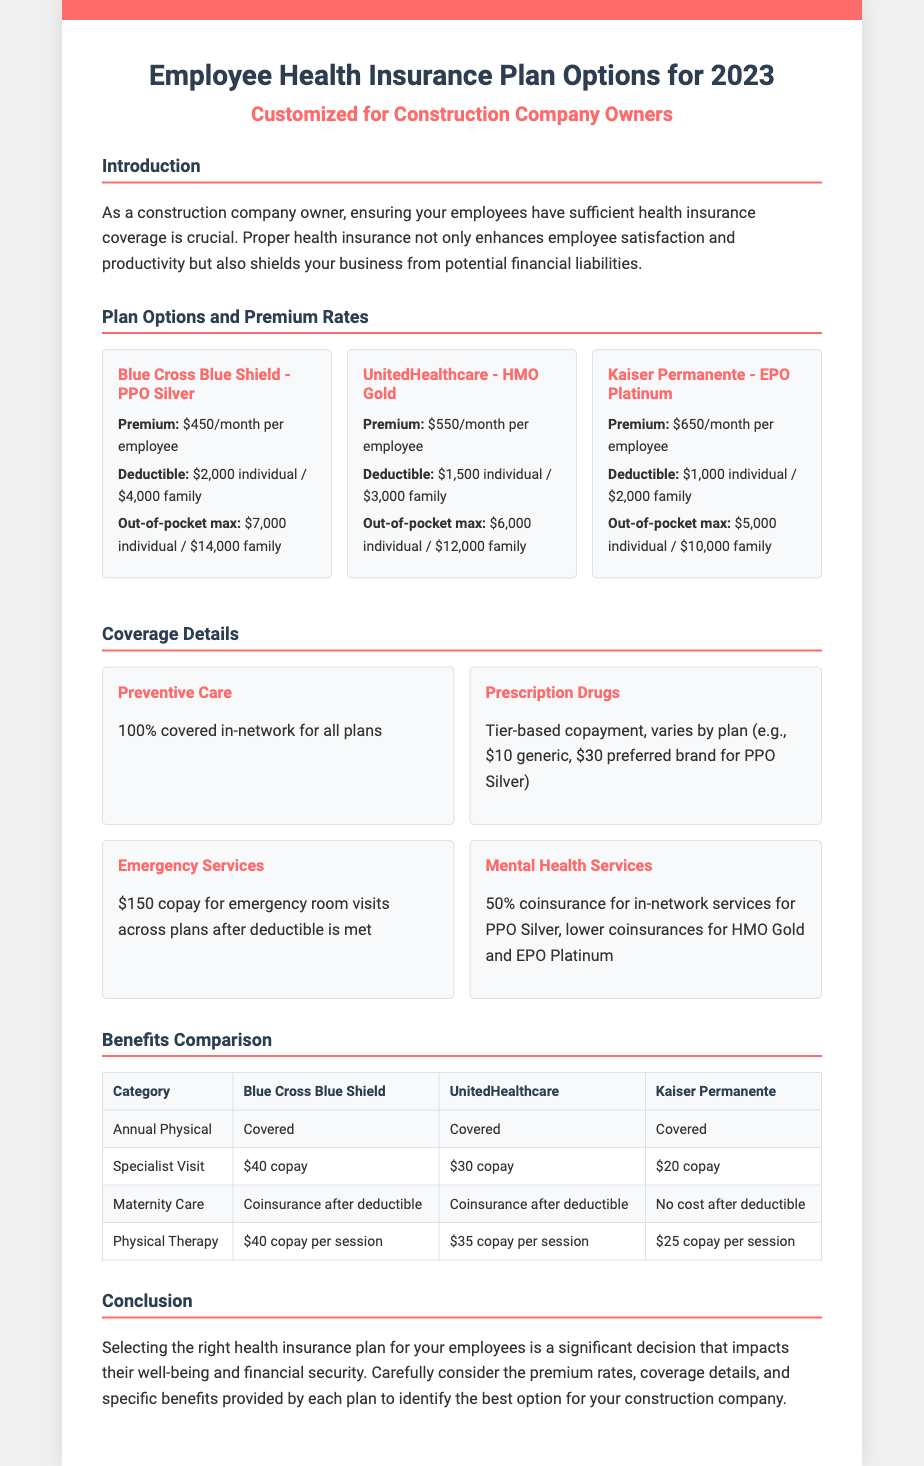What is the monthly premium for the Blue Cross Blue Shield plan? The monthly premium is specified as $450 per employee for the Blue Cross Blue Shield plan.
Answer: $450 What is the deductible for the UnitedHealthcare plan? The deductible for the UnitedHealthcare plan is detailed as $1,500 individual / $3,000 family.
Answer: $1,500 individual / $3,000 family What percentage of preventive care is covered in-network? The document states that preventive care is covered at 100% in-network for all plans.
Answer: 100% How much is the copay for a specialist visit for Kaiser Permanente? The copay for a specialist visit under Kaiser Permanente is indicated as $20.
Answer: $20 Which plan has the highest out-of-pocket maximum? The out-of-pocket maximum is highest for the Blue Cross Blue Shield plan, as listed.
Answer: Blue Cross Blue Shield What type of document is this? The title indicates it is about Employee Health Insurance Plan Options for 2023.
Answer: Employee Health Insurance Plan Options What benefit is free after deductible under Kaiser Permanente? The document mentions that maternity care incurs no cost after the deductible for Kaiser Permanente.
Answer: No cost after deductible Which plan has the lowest monthly premium? The monthly premium comparison indicates that Blue Cross Blue Shield has the lowest rate among the listed plans.
Answer: Blue Cross Blue Shield 